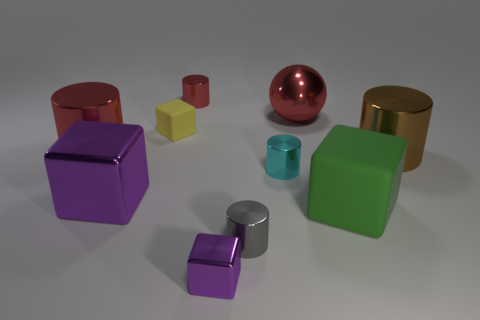Subtract 1 cylinders. How many cylinders are left? 4 Subtract all cyan metallic cylinders. How many cylinders are left? 4 Subtract all purple cylinders. Subtract all gray balls. How many cylinders are left? 5 Subtract all blocks. How many objects are left? 6 Subtract all red shiny cylinders. Subtract all blocks. How many objects are left? 4 Add 1 cyan things. How many cyan things are left? 2 Add 3 big brown things. How many big brown things exist? 4 Subtract 1 purple cubes. How many objects are left? 9 